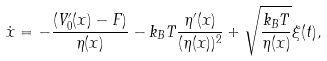Convert formula to latex. <formula><loc_0><loc_0><loc_500><loc_500>\dot { x } = - \frac { ( V ^ { \prime } _ { 0 } ( x ) - F ) } { \eta ( x ) } - k _ { B } T \frac { \eta ^ { \prime } ( x ) } { ( \eta ( x ) ) ^ { 2 } } + \sqrt { \frac { k _ { B } T } { \eta ( x ) } } \xi ( t ) ,</formula> 